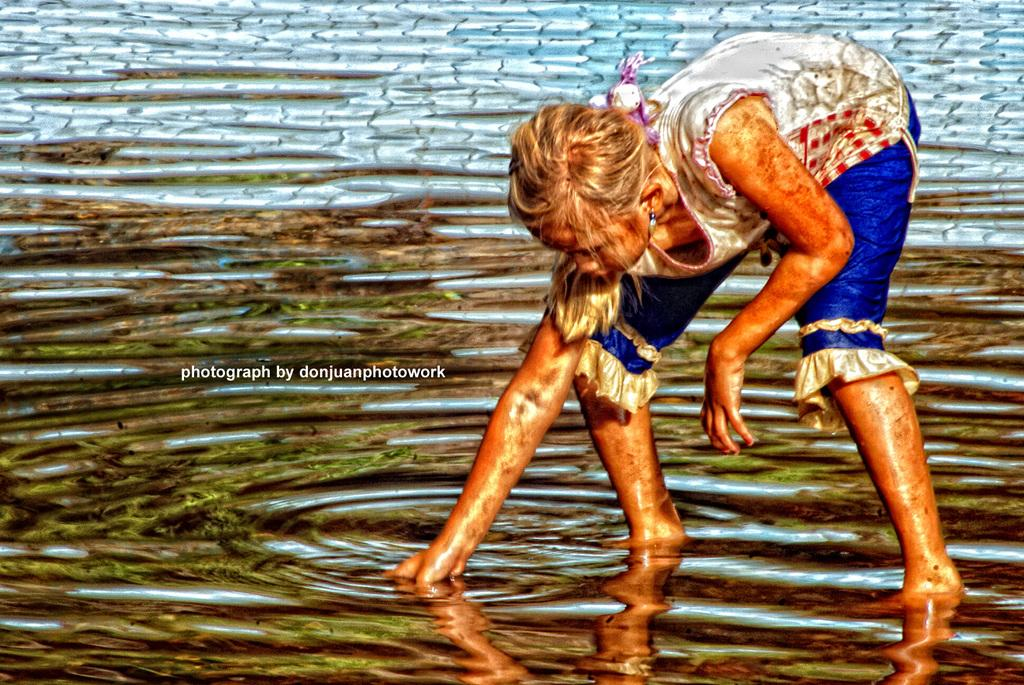What is the primary element in the image? There is water in the image. Can you describe the girl in the image? The girl is in the front of the image, wearing a white top and blue pants. What is the color of the girl's top? The girl is wearing a white top. What is the color of the girl's pants? The girl is wearing blue pants. Is there any additional mark or feature on the image? Yes, there is a watermark on the left side of the image. How many mice are playing with the girl in the image? There are no mice present in the image; it only features a girl and water. Is there a notebook visible in the image? There is no notebook present in the image. 